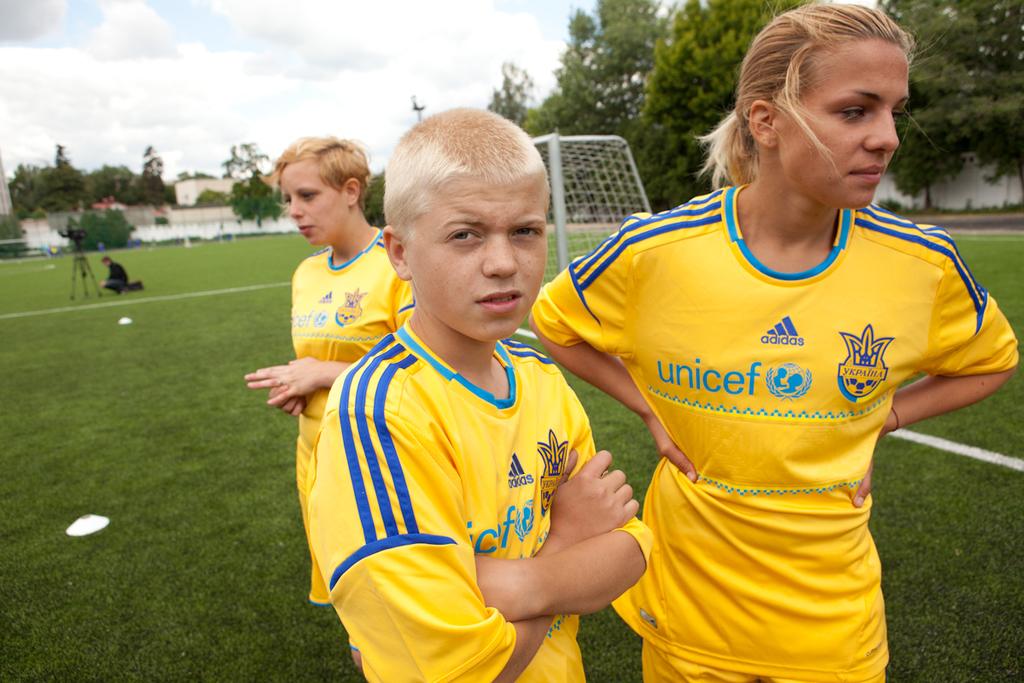What is the brand of uniform?
Your response must be concise. Adidas. 